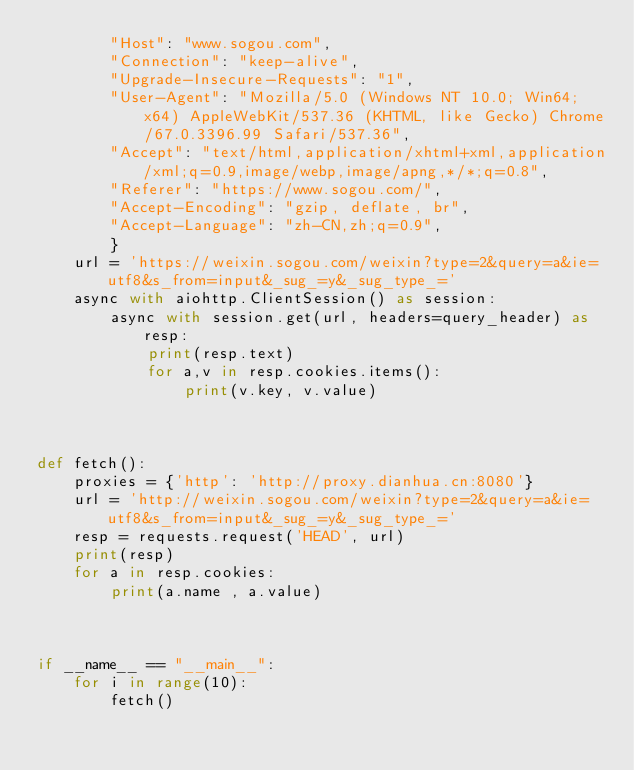<code> <loc_0><loc_0><loc_500><loc_500><_Python_>        "Host": "www.sogou.com",
        "Connection": "keep-alive",
        "Upgrade-Insecure-Requests": "1",
        "User-Agent": "Mozilla/5.0 (Windows NT 10.0; Win64; x64) AppleWebKit/537.36 (KHTML, like Gecko) Chrome/67.0.3396.99 Safari/537.36",
        "Accept": "text/html,application/xhtml+xml,application/xml;q=0.9,image/webp,image/apng,*/*;q=0.8",
        "Referer": "https://www.sogou.com/",
        "Accept-Encoding": "gzip, deflate, br",
        "Accept-Language": "zh-CN,zh;q=0.9",
        }
    url = 'https://weixin.sogou.com/weixin?type=2&query=a&ie=utf8&s_from=input&_sug_=y&_sug_type_=' 
    async with aiohttp.ClientSession() as session:
        async with session.get(url, headers=query_header) as resp:
            print(resp.text)
            for a,v in resp.cookies.items():
                print(v.key, v.value)
            


def fetch():
    proxies = {'http': 'http://proxy.dianhua.cn:8080'}
    url = 'http://weixin.sogou.com/weixin?type=2&query=a&ie=utf8&s_from=input&_sug_=y&_sug_type_='
    resp = requests.request('HEAD', url)
    print(resp)
    for a in resp.cookies:
        print(a.name , a.value)
    


if __name__ == "__main__":
    for i in range(10):
        fetch()
</code> 